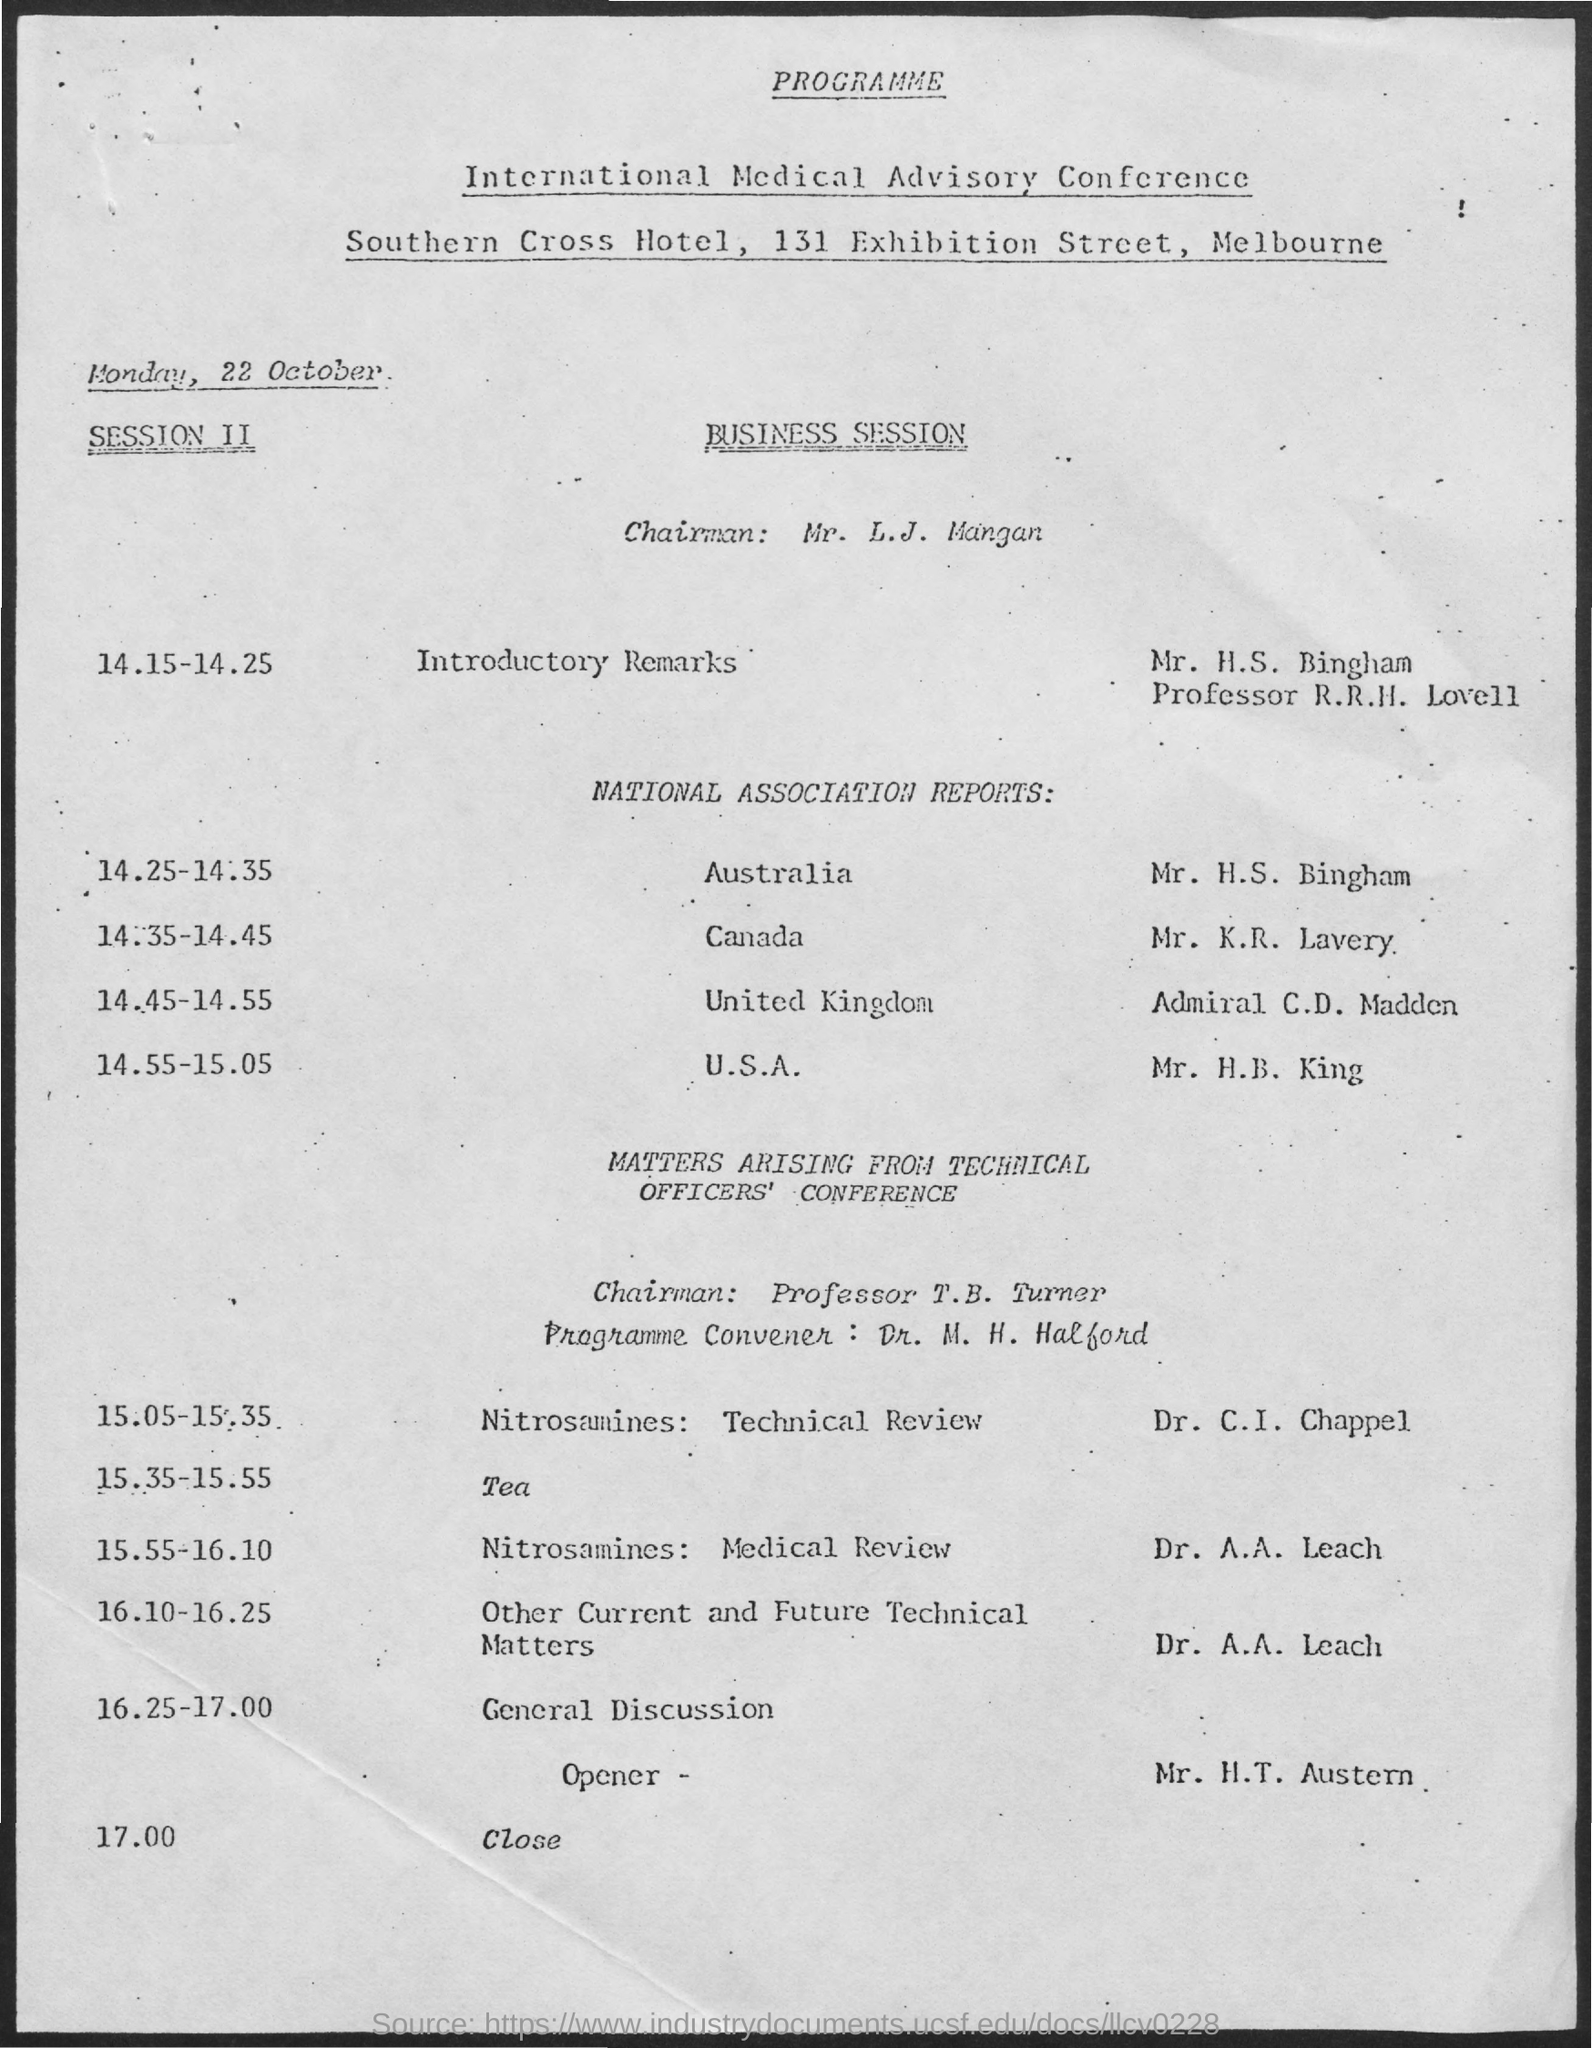When is the International Medical Advisory Conference held?
Keep it short and to the point. Monday, 22 October. Who is the Chairman for Business Session?
Make the answer very short. Mr. L.J. Mangan. Who is presenting the indroductory remarks in session II?
Provide a succinct answer. Mr. H.S. Bingham. What is the designation of Mr. H.S. Bingham?
Provide a succinct answer. Professor R.R.H. Lovell. Who is the Program Convener for the matters arising  from technical officers' conference?
Provide a short and direct response. Dr. M. H. Halford. Who is the Chairman for the matters arising from technical officers' conference?
Your answer should be very brief. Professor T.B. Turner. Who is presenting Nitrosamines: Medical review for the session?
Provide a short and direct response. Dr. A.A. Leach. What time is the other current and future technical matters by Dr. A.A. Leach scheduled?
Your response must be concise. 16.10-16.25. Who is presenting the National Association  Reports for Canada in the business session?
Your answer should be very brief. Mr. K.R. Lavery. 